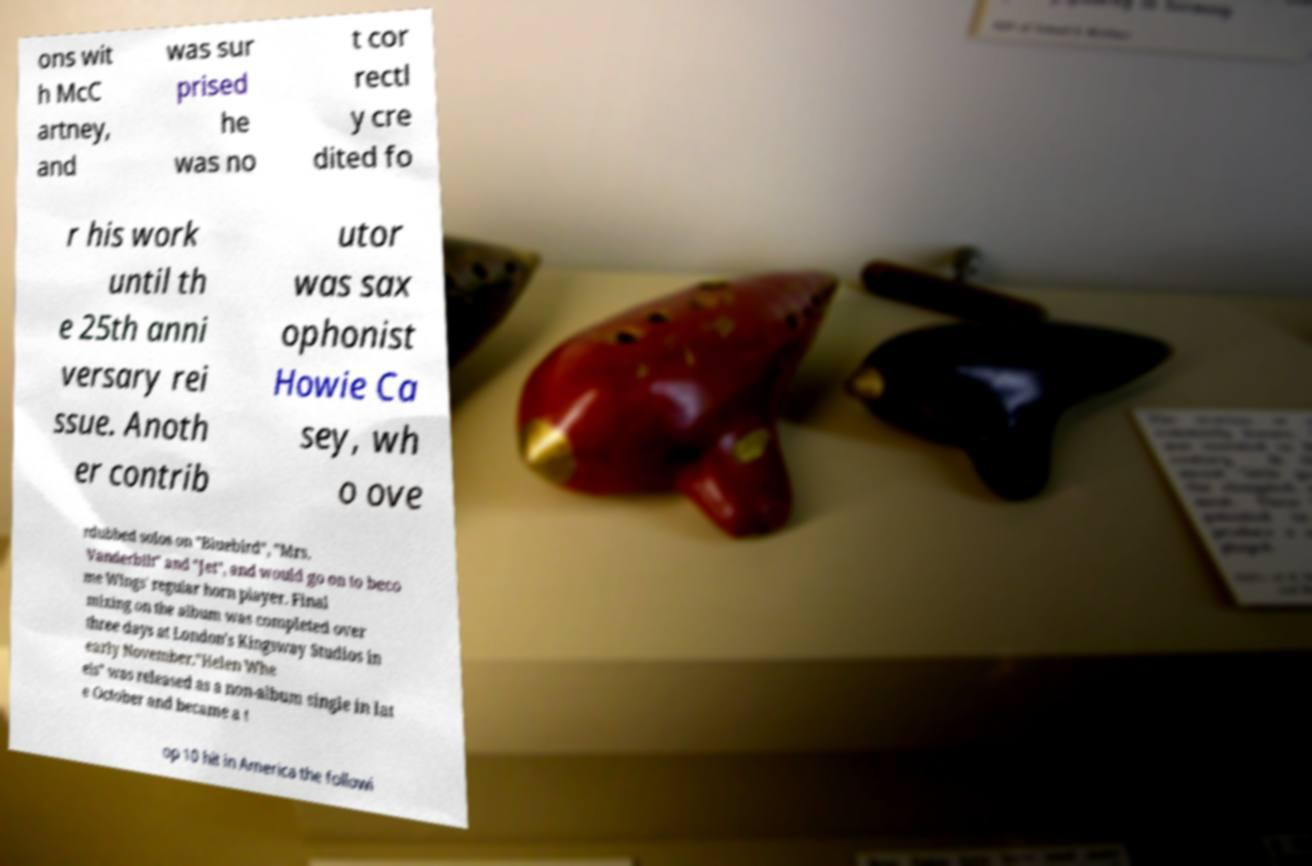Could you extract and type out the text from this image? ons wit h McC artney, and was sur prised he was no t cor rectl y cre dited fo r his work until th e 25th anni versary rei ssue. Anoth er contrib utor was sax ophonist Howie Ca sey, wh o ove rdubbed solos on "Bluebird", "Mrs. Vanderbilt" and "Jet", and would go on to beco me Wings' regular horn player. Final mixing on the album was completed over three days at London's Kingsway Studios in early November."Helen Whe els" was released as a non-album single in lat e October and became a t op 10 hit in America the followi 